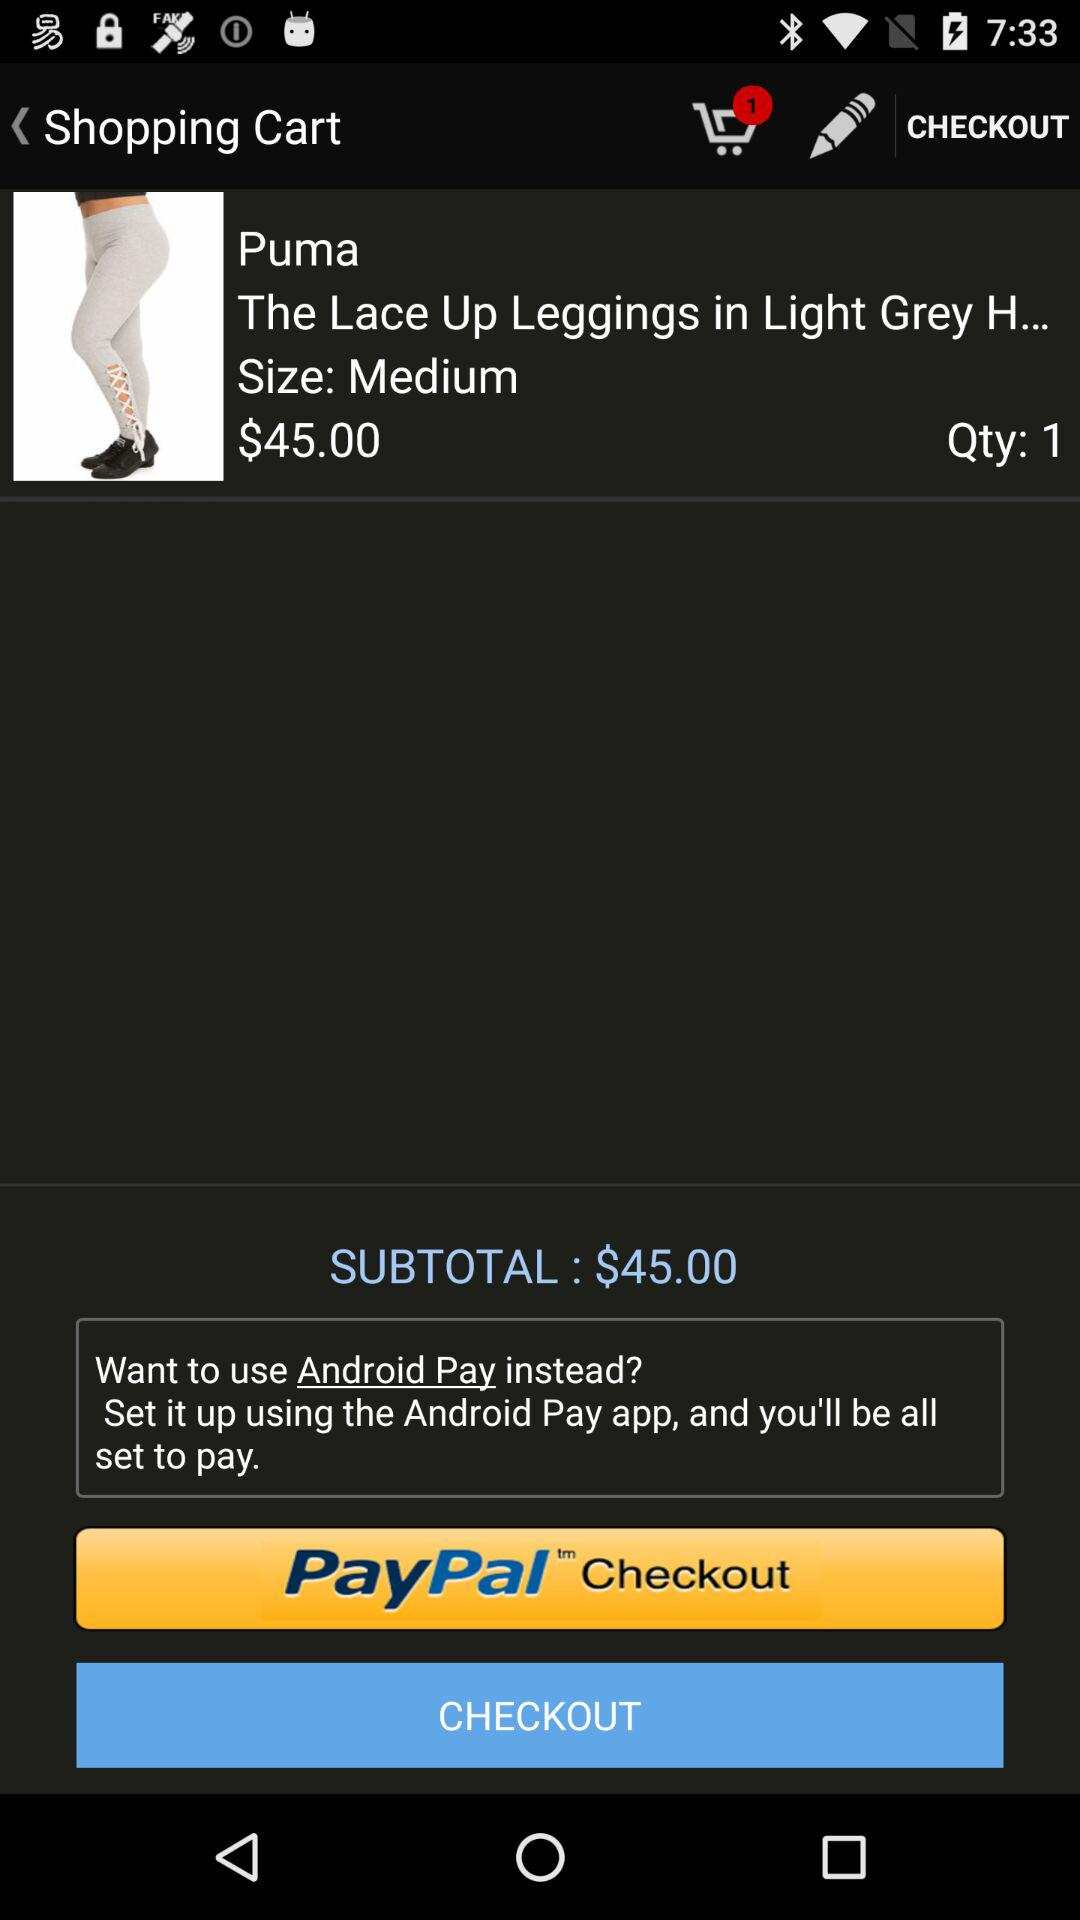How many items are in the cart? There is one item in the cart. 